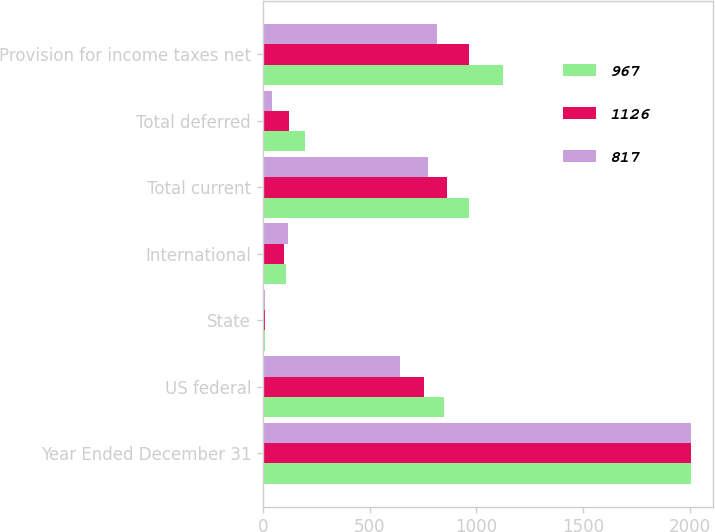Convert chart. <chart><loc_0><loc_0><loc_500><loc_500><stacked_bar_chart><ecel><fcel>Year Ended December 31<fcel>US federal<fcel>State<fcel>International<fcel>Total current<fcel>Total deferred<fcel>Provision for income taxes net<nl><fcel>967<fcel>2008<fcel>847<fcel>11<fcel>107<fcel>965<fcel>196<fcel>1126<nl><fcel>1126<fcel>2007<fcel>756<fcel>9<fcel>98<fcel>863<fcel>122<fcel>967<nl><fcel>817<fcel>2006<fcel>642<fcel>12<fcel>118<fcel>772<fcel>45<fcel>817<nl></chart> 